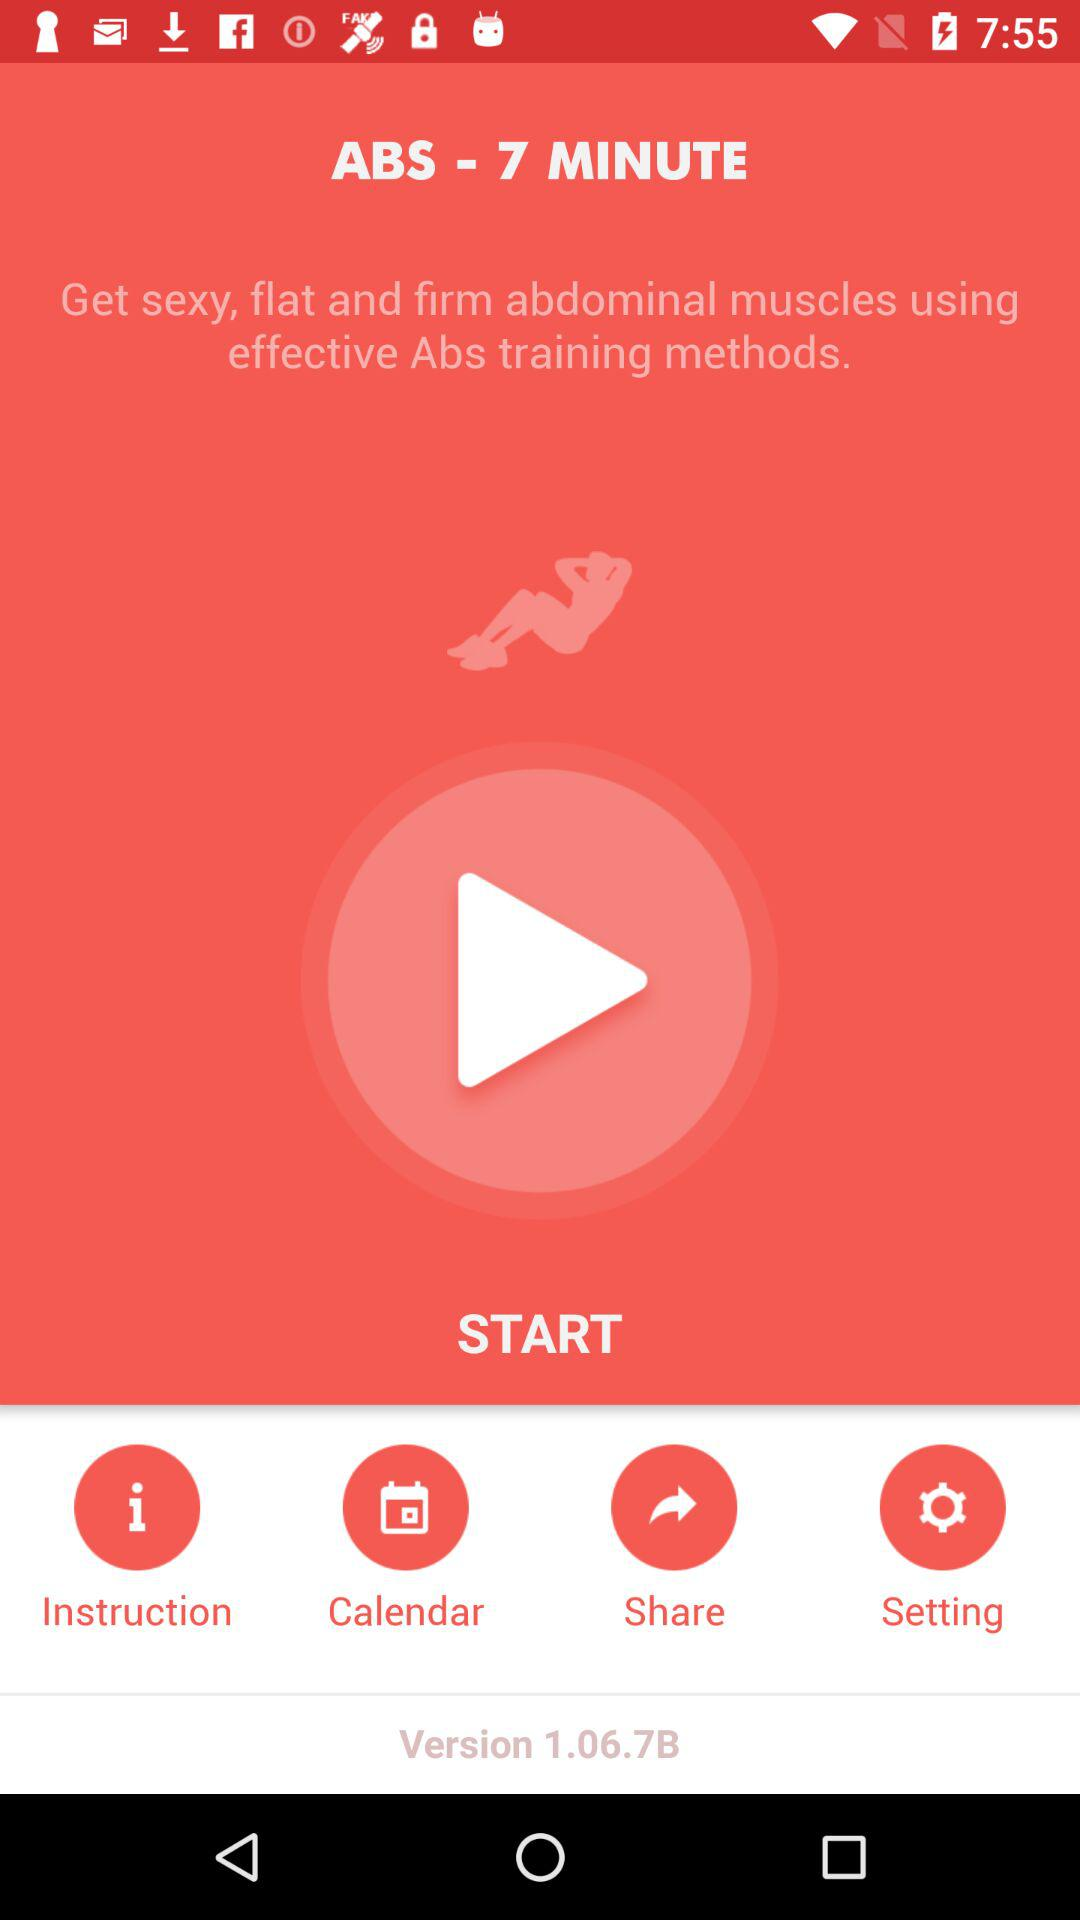How long does it take for Abs training? It takes 7 minutes for Abs training. 